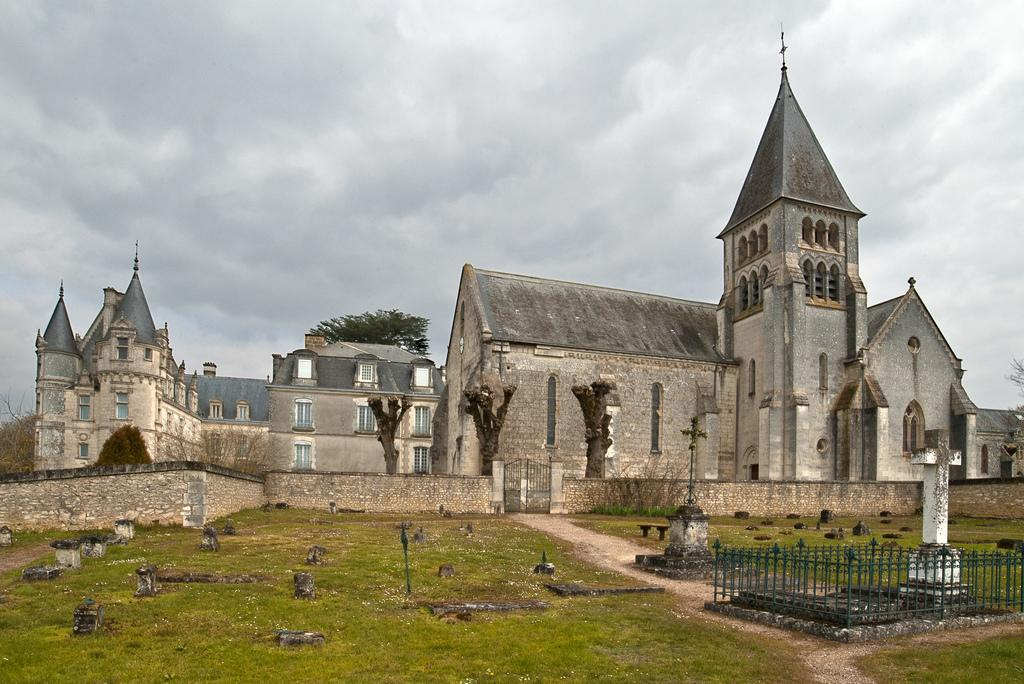What type of structure is present in the image? There is a building in the image. What other features can be seen in the image? There are cemeteries and trees visible in the image. How many girls are playing the horn in the image? There are no girls or horns present in the image. 